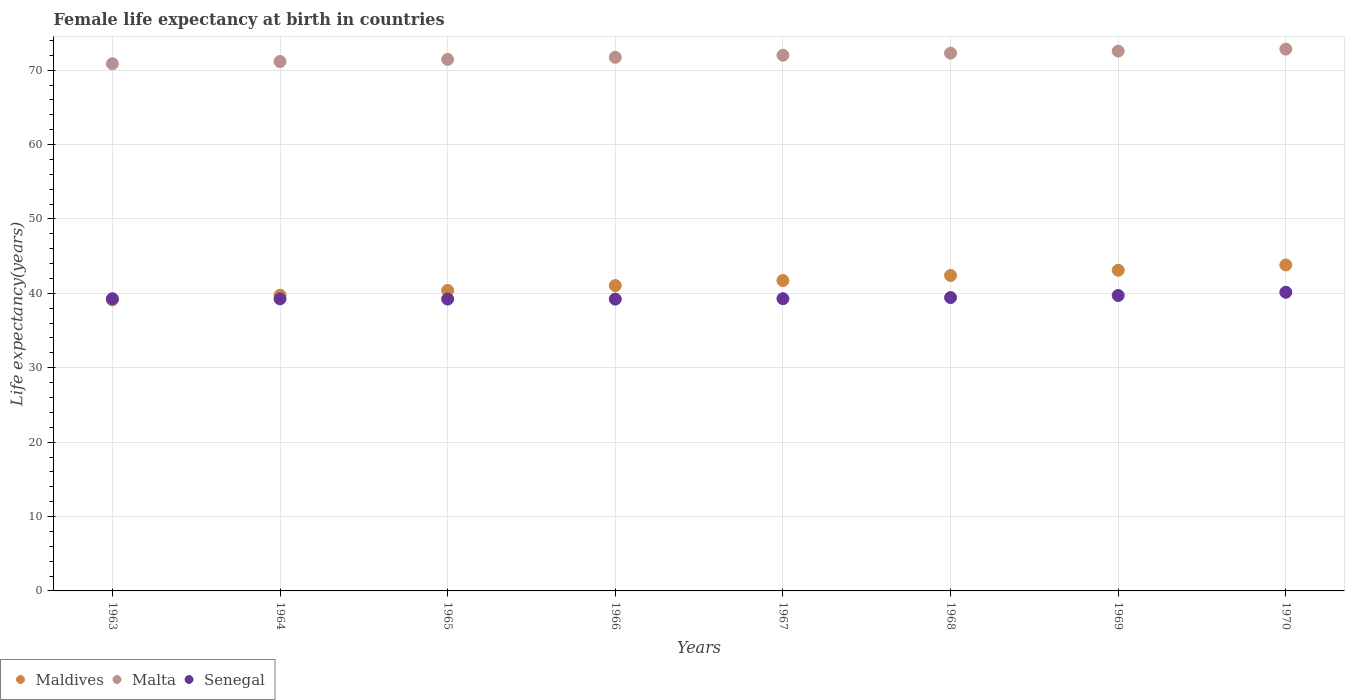Is the number of dotlines equal to the number of legend labels?
Your answer should be compact. Yes. What is the female life expectancy at birth in Maldives in 1964?
Give a very brief answer. 39.75. Across all years, what is the maximum female life expectancy at birth in Malta?
Give a very brief answer. 72.82. Across all years, what is the minimum female life expectancy at birth in Senegal?
Provide a succinct answer. 39.22. In which year was the female life expectancy at birth in Malta maximum?
Your answer should be very brief. 1970. In which year was the female life expectancy at birth in Senegal minimum?
Make the answer very short. 1966. What is the total female life expectancy at birth in Malta in the graph?
Provide a short and direct response. 574.84. What is the difference between the female life expectancy at birth in Malta in 1965 and that in 1970?
Ensure brevity in your answer.  -1.38. What is the difference between the female life expectancy at birth in Senegal in 1967 and the female life expectancy at birth in Malta in 1968?
Keep it short and to the point. -33. What is the average female life expectancy at birth in Malta per year?
Your answer should be compact. 71.86. In the year 1965, what is the difference between the female life expectancy at birth in Maldives and female life expectancy at birth in Senegal?
Offer a very short reply. 1.16. What is the ratio of the female life expectancy at birth in Senegal in 1967 to that in 1970?
Give a very brief answer. 0.98. Is the female life expectancy at birth in Malta in 1965 less than that in 1968?
Your response must be concise. Yes. Is the difference between the female life expectancy at birth in Maldives in 1963 and 1967 greater than the difference between the female life expectancy at birth in Senegal in 1963 and 1967?
Give a very brief answer. No. What is the difference between the highest and the second highest female life expectancy at birth in Maldives?
Offer a very short reply. 0.71. What is the difference between the highest and the lowest female life expectancy at birth in Senegal?
Offer a terse response. 0.92. Is it the case that in every year, the sum of the female life expectancy at birth in Maldives and female life expectancy at birth in Malta  is greater than the female life expectancy at birth in Senegal?
Keep it short and to the point. Yes. How many years are there in the graph?
Offer a very short reply. 8. Where does the legend appear in the graph?
Make the answer very short. Bottom left. How many legend labels are there?
Make the answer very short. 3. What is the title of the graph?
Your answer should be very brief. Female life expectancy at birth in countries. Does "Kyrgyz Republic" appear as one of the legend labels in the graph?
Your answer should be very brief. No. What is the label or title of the Y-axis?
Your answer should be very brief. Life expectancy(years). What is the Life expectancy(years) of Maldives in 1963?
Offer a very short reply. 39.12. What is the Life expectancy(years) in Malta in 1963?
Ensure brevity in your answer.  70.86. What is the Life expectancy(years) of Senegal in 1963?
Provide a succinct answer. 39.27. What is the Life expectancy(years) in Maldives in 1964?
Your response must be concise. 39.75. What is the Life expectancy(years) in Malta in 1964?
Provide a succinct answer. 71.15. What is the Life expectancy(years) of Senegal in 1964?
Provide a short and direct response. 39.26. What is the Life expectancy(years) of Maldives in 1965?
Your answer should be compact. 40.39. What is the Life expectancy(years) in Malta in 1965?
Offer a very short reply. 71.44. What is the Life expectancy(years) of Senegal in 1965?
Your answer should be compact. 39.23. What is the Life expectancy(years) of Maldives in 1966?
Give a very brief answer. 41.05. What is the Life expectancy(years) of Malta in 1966?
Provide a succinct answer. 71.72. What is the Life expectancy(years) of Senegal in 1966?
Your answer should be very brief. 39.22. What is the Life expectancy(years) of Maldives in 1967?
Give a very brief answer. 41.72. What is the Life expectancy(years) of Malta in 1967?
Provide a succinct answer. 72. What is the Life expectancy(years) of Senegal in 1967?
Make the answer very short. 39.28. What is the Life expectancy(years) of Maldives in 1968?
Make the answer very short. 42.4. What is the Life expectancy(years) of Malta in 1968?
Ensure brevity in your answer.  72.28. What is the Life expectancy(years) in Senegal in 1968?
Provide a succinct answer. 39.43. What is the Life expectancy(years) of Maldives in 1969?
Your answer should be very brief. 43.1. What is the Life expectancy(years) of Malta in 1969?
Make the answer very short. 72.55. What is the Life expectancy(years) in Senegal in 1969?
Offer a terse response. 39.71. What is the Life expectancy(years) of Maldives in 1970?
Your response must be concise. 43.81. What is the Life expectancy(years) in Malta in 1970?
Give a very brief answer. 72.82. What is the Life expectancy(years) in Senegal in 1970?
Your answer should be very brief. 40.14. Across all years, what is the maximum Life expectancy(years) in Maldives?
Make the answer very short. 43.81. Across all years, what is the maximum Life expectancy(years) of Malta?
Provide a short and direct response. 72.82. Across all years, what is the maximum Life expectancy(years) in Senegal?
Offer a terse response. 40.14. Across all years, what is the minimum Life expectancy(years) in Maldives?
Offer a terse response. 39.12. Across all years, what is the minimum Life expectancy(years) of Malta?
Provide a succinct answer. 70.86. Across all years, what is the minimum Life expectancy(years) in Senegal?
Make the answer very short. 39.22. What is the total Life expectancy(years) in Maldives in the graph?
Offer a terse response. 331.34. What is the total Life expectancy(years) of Malta in the graph?
Your answer should be very brief. 574.84. What is the total Life expectancy(years) of Senegal in the graph?
Make the answer very short. 315.54. What is the difference between the Life expectancy(years) of Maldives in 1963 and that in 1964?
Your answer should be very brief. -0.62. What is the difference between the Life expectancy(years) of Malta in 1963 and that in 1964?
Your response must be concise. -0.29. What is the difference between the Life expectancy(years) in Senegal in 1963 and that in 1964?
Your answer should be compact. 0.02. What is the difference between the Life expectancy(years) in Maldives in 1963 and that in 1965?
Make the answer very short. -1.27. What is the difference between the Life expectancy(years) in Malta in 1963 and that in 1965?
Make the answer very short. -0.58. What is the difference between the Life expectancy(years) of Senegal in 1963 and that in 1965?
Provide a succinct answer. 0.04. What is the difference between the Life expectancy(years) in Maldives in 1963 and that in 1966?
Offer a terse response. -1.92. What is the difference between the Life expectancy(years) of Malta in 1963 and that in 1966?
Your response must be concise. -0.86. What is the difference between the Life expectancy(years) in Senegal in 1963 and that in 1966?
Your response must be concise. 0.05. What is the difference between the Life expectancy(years) of Maldives in 1963 and that in 1967?
Provide a succinct answer. -2.59. What is the difference between the Life expectancy(years) in Malta in 1963 and that in 1967?
Make the answer very short. -1.14. What is the difference between the Life expectancy(years) of Senegal in 1963 and that in 1967?
Provide a succinct answer. -0.01. What is the difference between the Life expectancy(years) in Maldives in 1963 and that in 1968?
Your answer should be compact. -3.28. What is the difference between the Life expectancy(years) in Malta in 1963 and that in 1968?
Provide a short and direct response. -1.42. What is the difference between the Life expectancy(years) of Senegal in 1963 and that in 1968?
Provide a short and direct response. -0.16. What is the difference between the Life expectancy(years) in Maldives in 1963 and that in 1969?
Provide a succinct answer. -3.98. What is the difference between the Life expectancy(years) of Malta in 1963 and that in 1969?
Give a very brief answer. -1.69. What is the difference between the Life expectancy(years) in Senegal in 1963 and that in 1969?
Offer a very short reply. -0.44. What is the difference between the Life expectancy(years) in Maldives in 1963 and that in 1970?
Provide a succinct answer. -4.68. What is the difference between the Life expectancy(years) in Malta in 1963 and that in 1970?
Make the answer very short. -1.96. What is the difference between the Life expectancy(years) of Senegal in 1963 and that in 1970?
Keep it short and to the point. -0.87. What is the difference between the Life expectancy(years) of Maldives in 1964 and that in 1965?
Provide a succinct answer. -0.64. What is the difference between the Life expectancy(years) of Malta in 1964 and that in 1965?
Offer a very short reply. -0.29. What is the difference between the Life expectancy(years) in Senegal in 1964 and that in 1965?
Make the answer very short. 0.03. What is the difference between the Life expectancy(years) in Maldives in 1964 and that in 1966?
Provide a short and direct response. -1.3. What is the difference between the Life expectancy(years) in Malta in 1964 and that in 1966?
Make the answer very short. -0.57. What is the difference between the Life expectancy(years) of Senegal in 1964 and that in 1966?
Provide a short and direct response. 0.03. What is the difference between the Life expectancy(years) of Maldives in 1964 and that in 1967?
Provide a succinct answer. -1.97. What is the difference between the Life expectancy(years) in Malta in 1964 and that in 1967?
Offer a terse response. -0.85. What is the difference between the Life expectancy(years) of Senegal in 1964 and that in 1967?
Give a very brief answer. -0.02. What is the difference between the Life expectancy(years) of Maldives in 1964 and that in 1968?
Keep it short and to the point. -2.65. What is the difference between the Life expectancy(years) in Malta in 1964 and that in 1968?
Your response must be concise. -1.13. What is the difference between the Life expectancy(years) of Senegal in 1964 and that in 1968?
Make the answer very short. -0.17. What is the difference between the Life expectancy(years) of Maldives in 1964 and that in 1969?
Your answer should be very brief. -3.35. What is the difference between the Life expectancy(years) in Malta in 1964 and that in 1969?
Ensure brevity in your answer.  -1.4. What is the difference between the Life expectancy(years) of Senegal in 1964 and that in 1969?
Give a very brief answer. -0.45. What is the difference between the Life expectancy(years) in Maldives in 1964 and that in 1970?
Give a very brief answer. -4.06. What is the difference between the Life expectancy(years) in Malta in 1964 and that in 1970?
Provide a short and direct response. -1.67. What is the difference between the Life expectancy(years) in Senegal in 1964 and that in 1970?
Offer a very short reply. -0.89. What is the difference between the Life expectancy(years) of Maldives in 1965 and that in 1966?
Keep it short and to the point. -0.66. What is the difference between the Life expectancy(years) in Malta in 1965 and that in 1966?
Provide a short and direct response. -0.28. What is the difference between the Life expectancy(years) of Senegal in 1965 and that in 1966?
Ensure brevity in your answer.  0.01. What is the difference between the Life expectancy(years) in Maldives in 1965 and that in 1967?
Your answer should be very brief. -1.33. What is the difference between the Life expectancy(years) of Malta in 1965 and that in 1967?
Your response must be concise. -0.56. What is the difference between the Life expectancy(years) of Maldives in 1965 and that in 1968?
Keep it short and to the point. -2.01. What is the difference between the Life expectancy(years) of Malta in 1965 and that in 1968?
Your response must be concise. -0.84. What is the difference between the Life expectancy(years) in Senegal in 1965 and that in 1968?
Offer a very short reply. -0.2. What is the difference between the Life expectancy(years) in Maldives in 1965 and that in 1969?
Offer a terse response. -2.71. What is the difference between the Life expectancy(years) in Malta in 1965 and that in 1969?
Offer a terse response. -1.11. What is the difference between the Life expectancy(years) of Senegal in 1965 and that in 1969?
Make the answer very short. -0.48. What is the difference between the Life expectancy(years) in Maldives in 1965 and that in 1970?
Your answer should be compact. -3.42. What is the difference between the Life expectancy(years) in Malta in 1965 and that in 1970?
Offer a terse response. -1.38. What is the difference between the Life expectancy(years) in Senegal in 1965 and that in 1970?
Ensure brevity in your answer.  -0.92. What is the difference between the Life expectancy(years) in Maldives in 1966 and that in 1967?
Provide a short and direct response. -0.67. What is the difference between the Life expectancy(years) in Malta in 1966 and that in 1967?
Give a very brief answer. -0.28. What is the difference between the Life expectancy(years) in Senegal in 1966 and that in 1967?
Provide a short and direct response. -0.06. What is the difference between the Life expectancy(years) in Maldives in 1966 and that in 1968?
Keep it short and to the point. -1.36. What is the difference between the Life expectancy(years) of Malta in 1966 and that in 1968?
Your answer should be compact. -0.56. What is the difference between the Life expectancy(years) in Senegal in 1966 and that in 1968?
Your response must be concise. -0.21. What is the difference between the Life expectancy(years) in Maldives in 1966 and that in 1969?
Keep it short and to the point. -2.05. What is the difference between the Life expectancy(years) of Malta in 1966 and that in 1969?
Provide a succinct answer. -0.83. What is the difference between the Life expectancy(years) in Senegal in 1966 and that in 1969?
Make the answer very short. -0.49. What is the difference between the Life expectancy(years) of Maldives in 1966 and that in 1970?
Provide a short and direct response. -2.76. What is the difference between the Life expectancy(years) of Malta in 1966 and that in 1970?
Offer a terse response. -1.1. What is the difference between the Life expectancy(years) in Senegal in 1966 and that in 1970?
Offer a terse response. -0.92. What is the difference between the Life expectancy(years) in Maldives in 1967 and that in 1968?
Give a very brief answer. -0.69. What is the difference between the Life expectancy(years) of Malta in 1967 and that in 1968?
Give a very brief answer. -0.28. What is the difference between the Life expectancy(years) in Senegal in 1967 and that in 1968?
Offer a very short reply. -0.15. What is the difference between the Life expectancy(years) of Maldives in 1967 and that in 1969?
Give a very brief answer. -1.38. What is the difference between the Life expectancy(years) of Malta in 1967 and that in 1969?
Your answer should be compact. -0.55. What is the difference between the Life expectancy(years) in Senegal in 1967 and that in 1969?
Your answer should be very brief. -0.43. What is the difference between the Life expectancy(years) of Maldives in 1967 and that in 1970?
Your answer should be very brief. -2.09. What is the difference between the Life expectancy(years) of Malta in 1967 and that in 1970?
Your response must be concise. -0.82. What is the difference between the Life expectancy(years) in Senegal in 1967 and that in 1970?
Offer a terse response. -0.86. What is the difference between the Life expectancy(years) of Maldives in 1968 and that in 1969?
Make the answer very short. -0.7. What is the difference between the Life expectancy(years) in Malta in 1968 and that in 1969?
Provide a short and direct response. -0.27. What is the difference between the Life expectancy(years) of Senegal in 1968 and that in 1969?
Provide a short and direct response. -0.28. What is the difference between the Life expectancy(years) in Maldives in 1968 and that in 1970?
Provide a succinct answer. -1.41. What is the difference between the Life expectancy(years) of Malta in 1968 and that in 1970?
Your answer should be compact. -0.54. What is the difference between the Life expectancy(years) of Senegal in 1968 and that in 1970?
Provide a short and direct response. -0.71. What is the difference between the Life expectancy(years) of Maldives in 1969 and that in 1970?
Provide a succinct answer. -0.71. What is the difference between the Life expectancy(years) of Malta in 1969 and that in 1970?
Make the answer very short. -0.27. What is the difference between the Life expectancy(years) of Senegal in 1969 and that in 1970?
Your answer should be very brief. -0.43. What is the difference between the Life expectancy(years) of Maldives in 1963 and the Life expectancy(years) of Malta in 1964?
Offer a very short reply. -32.03. What is the difference between the Life expectancy(years) in Maldives in 1963 and the Life expectancy(years) in Senegal in 1964?
Offer a very short reply. -0.13. What is the difference between the Life expectancy(years) of Malta in 1963 and the Life expectancy(years) of Senegal in 1964?
Give a very brief answer. 31.61. What is the difference between the Life expectancy(years) of Maldives in 1963 and the Life expectancy(years) of Malta in 1965?
Make the answer very short. -32.32. What is the difference between the Life expectancy(years) in Maldives in 1963 and the Life expectancy(years) in Senegal in 1965?
Your answer should be very brief. -0.1. What is the difference between the Life expectancy(years) of Malta in 1963 and the Life expectancy(years) of Senegal in 1965?
Make the answer very short. 31.63. What is the difference between the Life expectancy(years) of Maldives in 1963 and the Life expectancy(years) of Malta in 1966?
Provide a succinct answer. -32.6. What is the difference between the Life expectancy(years) of Maldives in 1963 and the Life expectancy(years) of Senegal in 1966?
Ensure brevity in your answer.  -0.1. What is the difference between the Life expectancy(years) of Malta in 1963 and the Life expectancy(years) of Senegal in 1966?
Keep it short and to the point. 31.64. What is the difference between the Life expectancy(years) in Maldives in 1963 and the Life expectancy(years) in Malta in 1967?
Keep it short and to the point. -32.88. What is the difference between the Life expectancy(years) of Maldives in 1963 and the Life expectancy(years) of Senegal in 1967?
Ensure brevity in your answer.  -0.15. What is the difference between the Life expectancy(years) of Malta in 1963 and the Life expectancy(years) of Senegal in 1967?
Your answer should be very brief. 31.58. What is the difference between the Life expectancy(years) of Maldives in 1963 and the Life expectancy(years) of Malta in 1968?
Your answer should be very brief. -33.16. What is the difference between the Life expectancy(years) of Maldives in 1963 and the Life expectancy(years) of Senegal in 1968?
Your answer should be very brief. -0.31. What is the difference between the Life expectancy(years) of Malta in 1963 and the Life expectancy(years) of Senegal in 1968?
Ensure brevity in your answer.  31.43. What is the difference between the Life expectancy(years) of Maldives in 1963 and the Life expectancy(years) of Malta in 1969?
Your answer should be compact. -33.43. What is the difference between the Life expectancy(years) of Maldives in 1963 and the Life expectancy(years) of Senegal in 1969?
Offer a very short reply. -0.58. What is the difference between the Life expectancy(years) in Malta in 1963 and the Life expectancy(years) in Senegal in 1969?
Ensure brevity in your answer.  31.15. What is the difference between the Life expectancy(years) in Maldives in 1963 and the Life expectancy(years) in Malta in 1970?
Ensure brevity in your answer.  -33.7. What is the difference between the Life expectancy(years) in Maldives in 1963 and the Life expectancy(years) in Senegal in 1970?
Make the answer very short. -1.02. What is the difference between the Life expectancy(years) in Malta in 1963 and the Life expectancy(years) in Senegal in 1970?
Give a very brief answer. 30.72. What is the difference between the Life expectancy(years) in Maldives in 1964 and the Life expectancy(years) in Malta in 1965?
Your answer should be very brief. -31.69. What is the difference between the Life expectancy(years) of Maldives in 1964 and the Life expectancy(years) of Senegal in 1965?
Give a very brief answer. 0.52. What is the difference between the Life expectancy(years) in Malta in 1964 and the Life expectancy(years) in Senegal in 1965?
Keep it short and to the point. 31.93. What is the difference between the Life expectancy(years) in Maldives in 1964 and the Life expectancy(years) in Malta in 1966?
Give a very brief answer. -31.98. What is the difference between the Life expectancy(years) in Maldives in 1964 and the Life expectancy(years) in Senegal in 1966?
Your answer should be compact. 0.53. What is the difference between the Life expectancy(years) of Malta in 1964 and the Life expectancy(years) of Senegal in 1966?
Provide a short and direct response. 31.93. What is the difference between the Life expectancy(years) in Maldives in 1964 and the Life expectancy(years) in Malta in 1967?
Your response must be concise. -32.26. What is the difference between the Life expectancy(years) in Maldives in 1964 and the Life expectancy(years) in Senegal in 1967?
Offer a terse response. 0.47. What is the difference between the Life expectancy(years) of Malta in 1964 and the Life expectancy(years) of Senegal in 1967?
Ensure brevity in your answer.  31.88. What is the difference between the Life expectancy(years) of Maldives in 1964 and the Life expectancy(years) of Malta in 1968?
Your answer should be very brief. -32.53. What is the difference between the Life expectancy(years) of Maldives in 1964 and the Life expectancy(years) of Senegal in 1968?
Your answer should be very brief. 0.32. What is the difference between the Life expectancy(years) of Malta in 1964 and the Life expectancy(years) of Senegal in 1968?
Provide a short and direct response. 31.72. What is the difference between the Life expectancy(years) in Maldives in 1964 and the Life expectancy(years) in Malta in 1969?
Provide a short and direct response. -32.81. What is the difference between the Life expectancy(years) of Maldives in 1964 and the Life expectancy(years) of Senegal in 1969?
Offer a terse response. 0.04. What is the difference between the Life expectancy(years) of Malta in 1964 and the Life expectancy(years) of Senegal in 1969?
Provide a succinct answer. 31.45. What is the difference between the Life expectancy(years) in Maldives in 1964 and the Life expectancy(years) in Malta in 1970?
Keep it short and to the point. -33.08. What is the difference between the Life expectancy(years) of Maldives in 1964 and the Life expectancy(years) of Senegal in 1970?
Your response must be concise. -0.4. What is the difference between the Life expectancy(years) in Malta in 1964 and the Life expectancy(years) in Senegal in 1970?
Provide a short and direct response. 31.01. What is the difference between the Life expectancy(years) of Maldives in 1965 and the Life expectancy(years) of Malta in 1966?
Keep it short and to the point. -31.33. What is the difference between the Life expectancy(years) in Maldives in 1965 and the Life expectancy(years) in Senegal in 1966?
Make the answer very short. 1.17. What is the difference between the Life expectancy(years) of Malta in 1965 and the Life expectancy(years) of Senegal in 1966?
Your response must be concise. 32.22. What is the difference between the Life expectancy(years) in Maldives in 1965 and the Life expectancy(years) in Malta in 1967?
Give a very brief answer. -31.61. What is the difference between the Life expectancy(years) of Maldives in 1965 and the Life expectancy(years) of Senegal in 1967?
Give a very brief answer. 1.11. What is the difference between the Life expectancy(years) in Malta in 1965 and the Life expectancy(years) in Senegal in 1967?
Make the answer very short. 32.16. What is the difference between the Life expectancy(years) of Maldives in 1965 and the Life expectancy(years) of Malta in 1968?
Make the answer very short. -31.89. What is the difference between the Life expectancy(years) of Malta in 1965 and the Life expectancy(years) of Senegal in 1968?
Give a very brief answer. 32.01. What is the difference between the Life expectancy(years) of Maldives in 1965 and the Life expectancy(years) of Malta in 1969?
Provide a succinct answer. -32.16. What is the difference between the Life expectancy(years) in Maldives in 1965 and the Life expectancy(years) in Senegal in 1969?
Keep it short and to the point. 0.68. What is the difference between the Life expectancy(years) of Malta in 1965 and the Life expectancy(years) of Senegal in 1969?
Offer a terse response. 31.73. What is the difference between the Life expectancy(years) of Maldives in 1965 and the Life expectancy(years) of Malta in 1970?
Ensure brevity in your answer.  -32.43. What is the difference between the Life expectancy(years) in Maldives in 1965 and the Life expectancy(years) in Senegal in 1970?
Offer a terse response. 0.25. What is the difference between the Life expectancy(years) of Malta in 1965 and the Life expectancy(years) of Senegal in 1970?
Keep it short and to the point. 31.3. What is the difference between the Life expectancy(years) of Maldives in 1966 and the Life expectancy(years) of Malta in 1967?
Offer a very short reply. -30.96. What is the difference between the Life expectancy(years) of Maldives in 1966 and the Life expectancy(years) of Senegal in 1967?
Provide a succinct answer. 1.77. What is the difference between the Life expectancy(years) in Malta in 1966 and the Life expectancy(years) in Senegal in 1967?
Your response must be concise. 32.45. What is the difference between the Life expectancy(years) of Maldives in 1966 and the Life expectancy(years) of Malta in 1968?
Provide a succinct answer. -31.23. What is the difference between the Life expectancy(years) of Maldives in 1966 and the Life expectancy(years) of Senegal in 1968?
Make the answer very short. 1.62. What is the difference between the Life expectancy(years) in Malta in 1966 and the Life expectancy(years) in Senegal in 1968?
Provide a short and direct response. 32.29. What is the difference between the Life expectancy(years) of Maldives in 1966 and the Life expectancy(years) of Malta in 1969?
Offer a terse response. -31.51. What is the difference between the Life expectancy(years) of Maldives in 1966 and the Life expectancy(years) of Senegal in 1969?
Provide a succinct answer. 1.34. What is the difference between the Life expectancy(years) of Malta in 1966 and the Life expectancy(years) of Senegal in 1969?
Provide a succinct answer. 32.02. What is the difference between the Life expectancy(years) in Maldives in 1966 and the Life expectancy(years) in Malta in 1970?
Your answer should be very brief. -31.78. What is the difference between the Life expectancy(years) of Maldives in 1966 and the Life expectancy(years) of Senegal in 1970?
Your answer should be compact. 0.9. What is the difference between the Life expectancy(years) in Malta in 1966 and the Life expectancy(years) in Senegal in 1970?
Provide a succinct answer. 31.58. What is the difference between the Life expectancy(years) in Maldives in 1967 and the Life expectancy(years) in Malta in 1968?
Offer a terse response. -30.56. What is the difference between the Life expectancy(years) in Maldives in 1967 and the Life expectancy(years) in Senegal in 1968?
Give a very brief answer. 2.29. What is the difference between the Life expectancy(years) of Malta in 1967 and the Life expectancy(years) of Senegal in 1968?
Offer a terse response. 32.57. What is the difference between the Life expectancy(years) in Maldives in 1967 and the Life expectancy(years) in Malta in 1969?
Offer a terse response. -30.84. What is the difference between the Life expectancy(years) in Maldives in 1967 and the Life expectancy(years) in Senegal in 1969?
Offer a very short reply. 2.01. What is the difference between the Life expectancy(years) in Malta in 1967 and the Life expectancy(years) in Senegal in 1969?
Keep it short and to the point. 32.3. What is the difference between the Life expectancy(years) in Maldives in 1967 and the Life expectancy(years) in Malta in 1970?
Your response must be concise. -31.11. What is the difference between the Life expectancy(years) of Maldives in 1967 and the Life expectancy(years) of Senegal in 1970?
Your response must be concise. 1.57. What is the difference between the Life expectancy(years) in Malta in 1967 and the Life expectancy(years) in Senegal in 1970?
Your answer should be very brief. 31.86. What is the difference between the Life expectancy(years) of Maldives in 1968 and the Life expectancy(years) of Malta in 1969?
Your answer should be very brief. -30.15. What is the difference between the Life expectancy(years) of Maldives in 1968 and the Life expectancy(years) of Senegal in 1969?
Provide a succinct answer. 2.69. What is the difference between the Life expectancy(years) of Malta in 1968 and the Life expectancy(years) of Senegal in 1969?
Offer a very short reply. 32.57. What is the difference between the Life expectancy(years) of Maldives in 1968 and the Life expectancy(years) of Malta in 1970?
Offer a terse response. -30.42. What is the difference between the Life expectancy(years) of Maldives in 1968 and the Life expectancy(years) of Senegal in 1970?
Offer a very short reply. 2.26. What is the difference between the Life expectancy(years) of Malta in 1968 and the Life expectancy(years) of Senegal in 1970?
Ensure brevity in your answer.  32.14. What is the difference between the Life expectancy(years) in Maldives in 1969 and the Life expectancy(years) in Malta in 1970?
Ensure brevity in your answer.  -29.72. What is the difference between the Life expectancy(years) of Maldives in 1969 and the Life expectancy(years) of Senegal in 1970?
Ensure brevity in your answer.  2.96. What is the difference between the Life expectancy(years) of Malta in 1969 and the Life expectancy(years) of Senegal in 1970?
Provide a succinct answer. 32.41. What is the average Life expectancy(years) in Maldives per year?
Your response must be concise. 41.42. What is the average Life expectancy(years) in Malta per year?
Provide a short and direct response. 71.86. What is the average Life expectancy(years) in Senegal per year?
Keep it short and to the point. 39.44. In the year 1963, what is the difference between the Life expectancy(years) in Maldives and Life expectancy(years) in Malta?
Your answer should be compact. -31.74. In the year 1963, what is the difference between the Life expectancy(years) in Maldives and Life expectancy(years) in Senegal?
Offer a terse response. -0.15. In the year 1963, what is the difference between the Life expectancy(years) of Malta and Life expectancy(years) of Senegal?
Ensure brevity in your answer.  31.59. In the year 1964, what is the difference between the Life expectancy(years) of Maldives and Life expectancy(years) of Malta?
Offer a terse response. -31.41. In the year 1964, what is the difference between the Life expectancy(years) of Maldives and Life expectancy(years) of Senegal?
Give a very brief answer. 0.49. In the year 1964, what is the difference between the Life expectancy(years) in Malta and Life expectancy(years) in Senegal?
Your answer should be very brief. 31.9. In the year 1965, what is the difference between the Life expectancy(years) of Maldives and Life expectancy(years) of Malta?
Your response must be concise. -31.05. In the year 1965, what is the difference between the Life expectancy(years) in Maldives and Life expectancy(years) in Senegal?
Offer a terse response. 1.16. In the year 1965, what is the difference between the Life expectancy(years) of Malta and Life expectancy(years) of Senegal?
Your answer should be very brief. 32.21. In the year 1966, what is the difference between the Life expectancy(years) of Maldives and Life expectancy(years) of Malta?
Offer a very short reply. -30.68. In the year 1966, what is the difference between the Life expectancy(years) of Maldives and Life expectancy(years) of Senegal?
Keep it short and to the point. 1.82. In the year 1966, what is the difference between the Life expectancy(years) of Malta and Life expectancy(years) of Senegal?
Your answer should be very brief. 32.5. In the year 1967, what is the difference between the Life expectancy(years) in Maldives and Life expectancy(years) in Malta?
Your response must be concise. -30.29. In the year 1967, what is the difference between the Life expectancy(years) of Maldives and Life expectancy(years) of Senegal?
Ensure brevity in your answer.  2.44. In the year 1967, what is the difference between the Life expectancy(years) in Malta and Life expectancy(years) in Senegal?
Give a very brief answer. 32.73. In the year 1968, what is the difference between the Life expectancy(years) in Maldives and Life expectancy(years) in Malta?
Your answer should be very brief. -29.88. In the year 1968, what is the difference between the Life expectancy(years) in Maldives and Life expectancy(years) in Senegal?
Ensure brevity in your answer.  2.97. In the year 1968, what is the difference between the Life expectancy(years) of Malta and Life expectancy(years) of Senegal?
Offer a very short reply. 32.85. In the year 1969, what is the difference between the Life expectancy(years) in Maldives and Life expectancy(years) in Malta?
Offer a terse response. -29.45. In the year 1969, what is the difference between the Life expectancy(years) in Maldives and Life expectancy(years) in Senegal?
Offer a terse response. 3.39. In the year 1969, what is the difference between the Life expectancy(years) of Malta and Life expectancy(years) of Senegal?
Your response must be concise. 32.85. In the year 1970, what is the difference between the Life expectancy(years) in Maldives and Life expectancy(years) in Malta?
Offer a very short reply. -29.02. In the year 1970, what is the difference between the Life expectancy(years) of Maldives and Life expectancy(years) of Senegal?
Offer a terse response. 3.67. In the year 1970, what is the difference between the Life expectancy(years) in Malta and Life expectancy(years) in Senegal?
Offer a terse response. 32.68. What is the ratio of the Life expectancy(years) in Maldives in 1963 to that in 1964?
Make the answer very short. 0.98. What is the ratio of the Life expectancy(years) of Malta in 1963 to that in 1964?
Your response must be concise. 1. What is the ratio of the Life expectancy(years) of Maldives in 1963 to that in 1965?
Your answer should be compact. 0.97. What is the ratio of the Life expectancy(years) of Maldives in 1963 to that in 1966?
Keep it short and to the point. 0.95. What is the ratio of the Life expectancy(years) of Senegal in 1963 to that in 1966?
Keep it short and to the point. 1. What is the ratio of the Life expectancy(years) in Maldives in 1963 to that in 1967?
Your response must be concise. 0.94. What is the ratio of the Life expectancy(years) of Malta in 1963 to that in 1967?
Give a very brief answer. 0.98. What is the ratio of the Life expectancy(years) in Maldives in 1963 to that in 1968?
Give a very brief answer. 0.92. What is the ratio of the Life expectancy(years) in Malta in 1963 to that in 1968?
Keep it short and to the point. 0.98. What is the ratio of the Life expectancy(years) in Maldives in 1963 to that in 1969?
Make the answer very short. 0.91. What is the ratio of the Life expectancy(years) of Malta in 1963 to that in 1969?
Give a very brief answer. 0.98. What is the ratio of the Life expectancy(years) of Senegal in 1963 to that in 1969?
Your answer should be compact. 0.99. What is the ratio of the Life expectancy(years) in Maldives in 1963 to that in 1970?
Keep it short and to the point. 0.89. What is the ratio of the Life expectancy(years) in Senegal in 1963 to that in 1970?
Make the answer very short. 0.98. What is the ratio of the Life expectancy(years) in Maldives in 1964 to that in 1965?
Offer a terse response. 0.98. What is the ratio of the Life expectancy(years) of Malta in 1964 to that in 1965?
Ensure brevity in your answer.  1. What is the ratio of the Life expectancy(years) in Senegal in 1964 to that in 1965?
Your response must be concise. 1. What is the ratio of the Life expectancy(years) of Maldives in 1964 to that in 1966?
Offer a terse response. 0.97. What is the ratio of the Life expectancy(years) of Malta in 1964 to that in 1966?
Offer a very short reply. 0.99. What is the ratio of the Life expectancy(years) of Senegal in 1964 to that in 1966?
Offer a terse response. 1. What is the ratio of the Life expectancy(years) of Maldives in 1964 to that in 1967?
Ensure brevity in your answer.  0.95. What is the ratio of the Life expectancy(years) of Malta in 1964 to that in 1967?
Your response must be concise. 0.99. What is the ratio of the Life expectancy(years) of Maldives in 1964 to that in 1968?
Give a very brief answer. 0.94. What is the ratio of the Life expectancy(years) of Malta in 1964 to that in 1968?
Your answer should be compact. 0.98. What is the ratio of the Life expectancy(years) of Senegal in 1964 to that in 1968?
Provide a short and direct response. 1. What is the ratio of the Life expectancy(years) in Maldives in 1964 to that in 1969?
Provide a short and direct response. 0.92. What is the ratio of the Life expectancy(years) of Malta in 1964 to that in 1969?
Keep it short and to the point. 0.98. What is the ratio of the Life expectancy(years) in Maldives in 1964 to that in 1970?
Make the answer very short. 0.91. What is the ratio of the Life expectancy(years) in Malta in 1964 to that in 1970?
Provide a short and direct response. 0.98. What is the ratio of the Life expectancy(years) in Senegal in 1964 to that in 1970?
Provide a short and direct response. 0.98. What is the ratio of the Life expectancy(years) in Senegal in 1965 to that in 1966?
Provide a succinct answer. 1. What is the ratio of the Life expectancy(years) in Maldives in 1965 to that in 1967?
Offer a terse response. 0.97. What is the ratio of the Life expectancy(years) of Maldives in 1965 to that in 1968?
Offer a very short reply. 0.95. What is the ratio of the Life expectancy(years) of Malta in 1965 to that in 1968?
Ensure brevity in your answer.  0.99. What is the ratio of the Life expectancy(years) of Senegal in 1965 to that in 1968?
Your answer should be compact. 0.99. What is the ratio of the Life expectancy(years) of Maldives in 1965 to that in 1969?
Make the answer very short. 0.94. What is the ratio of the Life expectancy(years) in Malta in 1965 to that in 1969?
Keep it short and to the point. 0.98. What is the ratio of the Life expectancy(years) in Senegal in 1965 to that in 1969?
Provide a succinct answer. 0.99. What is the ratio of the Life expectancy(years) of Maldives in 1965 to that in 1970?
Keep it short and to the point. 0.92. What is the ratio of the Life expectancy(years) of Malta in 1965 to that in 1970?
Ensure brevity in your answer.  0.98. What is the ratio of the Life expectancy(years) of Senegal in 1965 to that in 1970?
Offer a very short reply. 0.98. What is the ratio of the Life expectancy(years) of Maldives in 1966 to that in 1967?
Provide a succinct answer. 0.98. What is the ratio of the Life expectancy(years) of Senegal in 1966 to that in 1968?
Offer a very short reply. 0.99. What is the ratio of the Life expectancy(years) in Maldives in 1966 to that in 1969?
Make the answer very short. 0.95. What is the ratio of the Life expectancy(years) in Senegal in 1966 to that in 1969?
Offer a terse response. 0.99. What is the ratio of the Life expectancy(years) of Maldives in 1966 to that in 1970?
Provide a short and direct response. 0.94. What is the ratio of the Life expectancy(years) in Malta in 1966 to that in 1970?
Your response must be concise. 0.98. What is the ratio of the Life expectancy(years) of Senegal in 1966 to that in 1970?
Provide a short and direct response. 0.98. What is the ratio of the Life expectancy(years) in Maldives in 1967 to that in 1968?
Give a very brief answer. 0.98. What is the ratio of the Life expectancy(years) in Senegal in 1967 to that in 1968?
Your response must be concise. 1. What is the ratio of the Life expectancy(years) in Maldives in 1967 to that in 1969?
Offer a very short reply. 0.97. What is the ratio of the Life expectancy(years) in Malta in 1967 to that in 1969?
Give a very brief answer. 0.99. What is the ratio of the Life expectancy(years) in Maldives in 1967 to that in 1970?
Ensure brevity in your answer.  0.95. What is the ratio of the Life expectancy(years) in Malta in 1967 to that in 1970?
Provide a succinct answer. 0.99. What is the ratio of the Life expectancy(years) in Senegal in 1967 to that in 1970?
Offer a terse response. 0.98. What is the ratio of the Life expectancy(years) of Maldives in 1968 to that in 1969?
Ensure brevity in your answer.  0.98. What is the ratio of the Life expectancy(years) in Malta in 1968 to that in 1969?
Offer a terse response. 1. What is the ratio of the Life expectancy(years) of Senegal in 1968 to that in 1969?
Give a very brief answer. 0.99. What is the ratio of the Life expectancy(years) in Maldives in 1968 to that in 1970?
Your answer should be compact. 0.97. What is the ratio of the Life expectancy(years) in Malta in 1968 to that in 1970?
Your response must be concise. 0.99. What is the ratio of the Life expectancy(years) in Senegal in 1968 to that in 1970?
Provide a short and direct response. 0.98. What is the ratio of the Life expectancy(years) in Maldives in 1969 to that in 1970?
Your answer should be compact. 0.98. What is the ratio of the Life expectancy(years) in Malta in 1969 to that in 1970?
Give a very brief answer. 1. What is the difference between the highest and the second highest Life expectancy(years) in Maldives?
Give a very brief answer. 0.71. What is the difference between the highest and the second highest Life expectancy(years) of Malta?
Provide a succinct answer. 0.27. What is the difference between the highest and the second highest Life expectancy(years) of Senegal?
Ensure brevity in your answer.  0.43. What is the difference between the highest and the lowest Life expectancy(years) of Maldives?
Provide a short and direct response. 4.68. What is the difference between the highest and the lowest Life expectancy(years) in Malta?
Offer a terse response. 1.96. What is the difference between the highest and the lowest Life expectancy(years) in Senegal?
Ensure brevity in your answer.  0.92. 